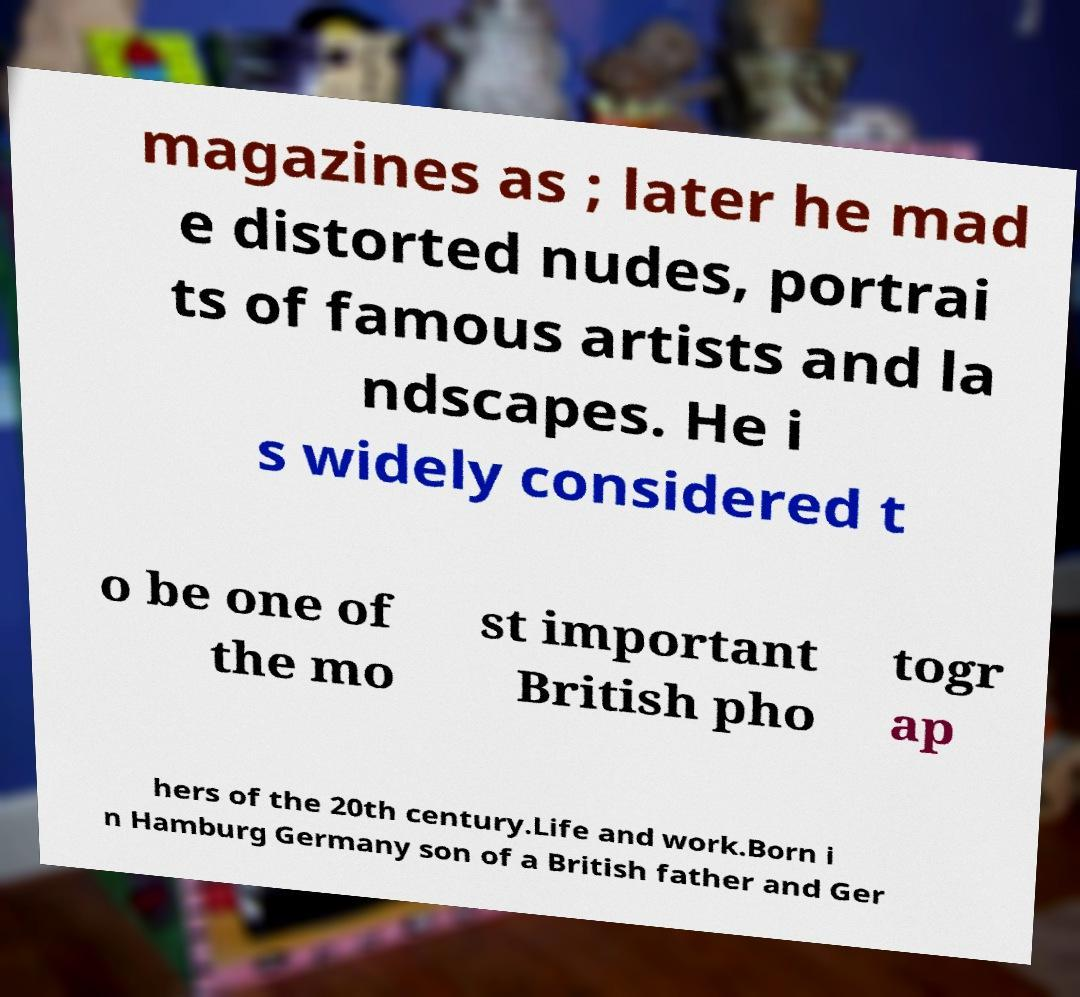Could you assist in decoding the text presented in this image and type it out clearly? magazines as ; later he mad e distorted nudes, portrai ts of famous artists and la ndscapes. He i s widely considered t o be one of the mo st important British pho togr ap hers of the 20th century.Life and work.Born i n Hamburg Germany son of a British father and Ger 